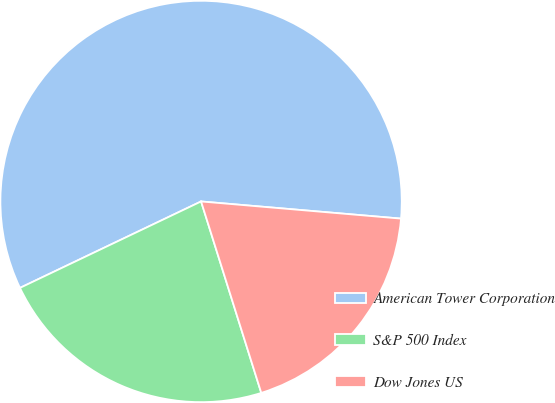<chart> <loc_0><loc_0><loc_500><loc_500><pie_chart><fcel>American Tower Corporation<fcel>S&P 500 Index<fcel>Dow Jones US<nl><fcel>58.45%<fcel>22.76%<fcel>18.79%<nl></chart> 